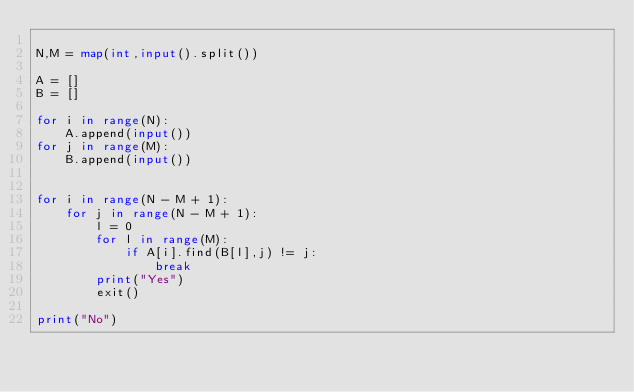Convert code to text. <code><loc_0><loc_0><loc_500><loc_500><_Python_>
N,M = map(int,input().split())

A = []
B = []

for i in range(N):
    A.append(input())
for j in range(M):
    B.append(input())


for i in range(N - M + 1):
    for j in range(N - M + 1):
        l = 0
        for l in range(M):
            if A[i].find(B[l],j) != j:
                break
        print("Yes")
        exit()

print("No")</code> 